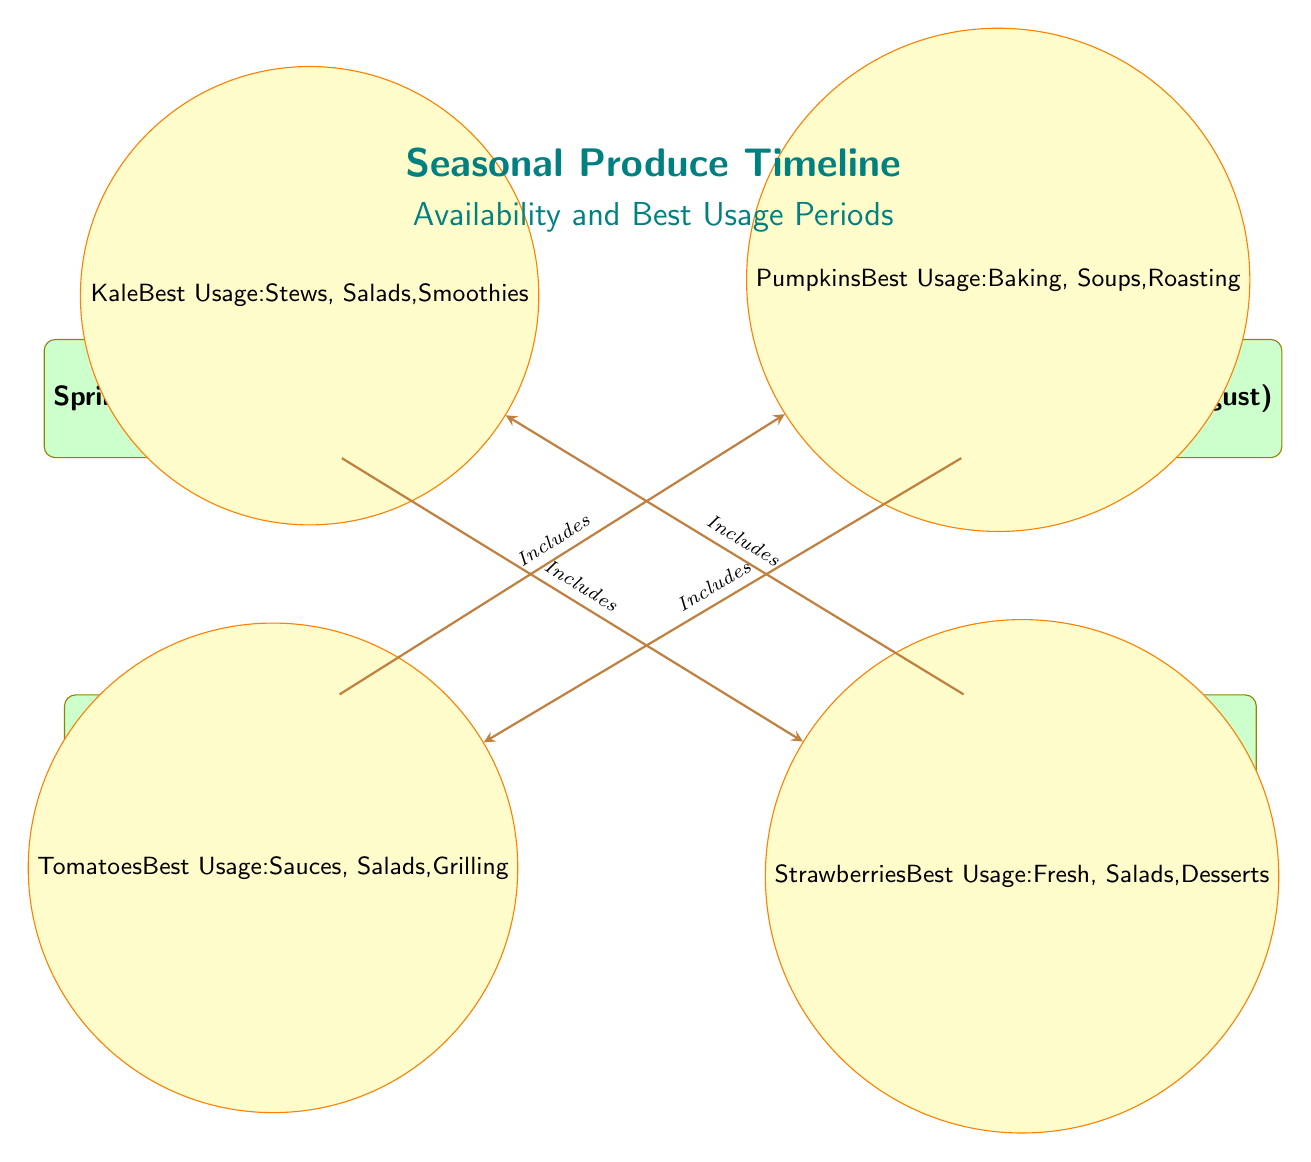What produce is available in spring? The diagram indicates that strawberries are available in the spring season. This information comes directly from the node labeled "Spring Produce" which includes the linked produce.
Answer: Strawberries Which season includes tomatoes? According to the diagram, tomatoes are included in the summer season as shown by the connection between the summer produce season node and the tomatoes node.
Answer: Summer What is the best usage for pumpkins? The diagram shows that the best usage for pumpkins is for baking, soups, and roasting. This is specified directly beneath the pumpkins node which details its usage.
Answer: Baking, Soups, Roasting How many produce types are listed in the diagram? The diagram includes a total of four produce types: strawberries, tomatoes, pumpkins, and kale. This can be counted directly from the produce nodes linked to the seasons.
Answer: Four What is the last season listed in the diagram? The last season depicted in the diagram is winter, as seen in the positioning of the nodes with winter at the bottom.
Answer: Winter Which season is placed directly above the fall season? Directly above the fall season in the diagram is summer, which can be observed from the vertical arrangement of the seasons.
Answer: Summer What produce corresponds to winter? The diagram specifies that kale corresponds to the winter season, indicated by the connection from the winter node to the kale node.
Answer: Kale During which months is spring produce available? Spring produce is available from March to May, as detailed within the spring season node in the diagram.
Answer: March - May What are the best usage suggestions for kale? The diagram indicates that kale is best used in stews, salads, and smoothies, which is stated beneath the kale node.
Answer: Stews, Salads, Smoothies 